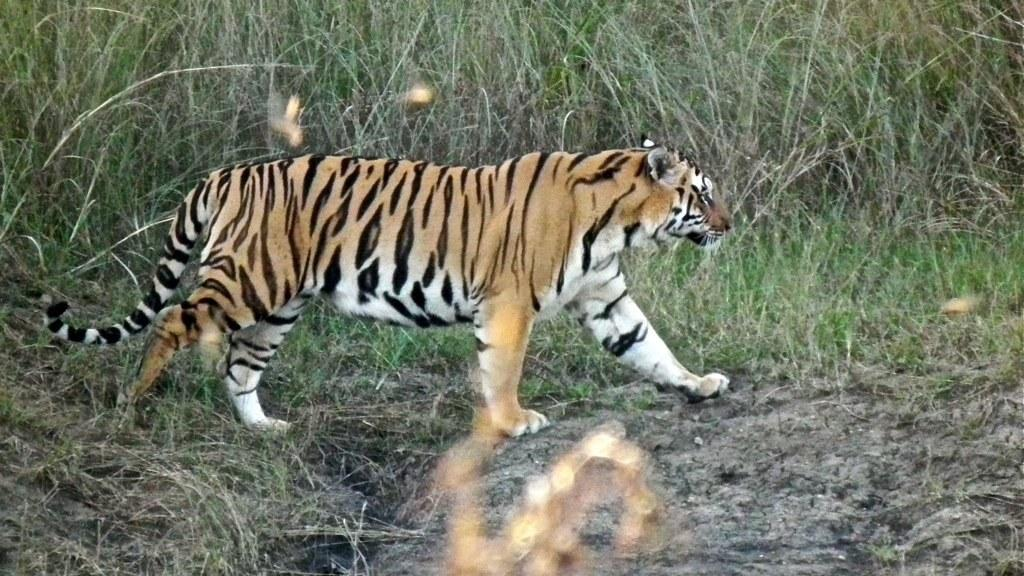What animal is present in the image? There is a tiger in the image. What is the tiger doing in the image? The tiger is walking. What type of vegetation can be seen in the background of the image? There are plants visible in the background. What type of terrain is present in the image? There is mud and grass in the image. How many grapes are being held by the tiger in the image? There are no grapes present in the image; it features a tiger walking in a grassy and muddy area with plants in the background. What type of sock is the tiger wearing on its front paw in the image? There are no socks present in the image; it features a tiger walking in a grassy and muddy area with plants in the background. 